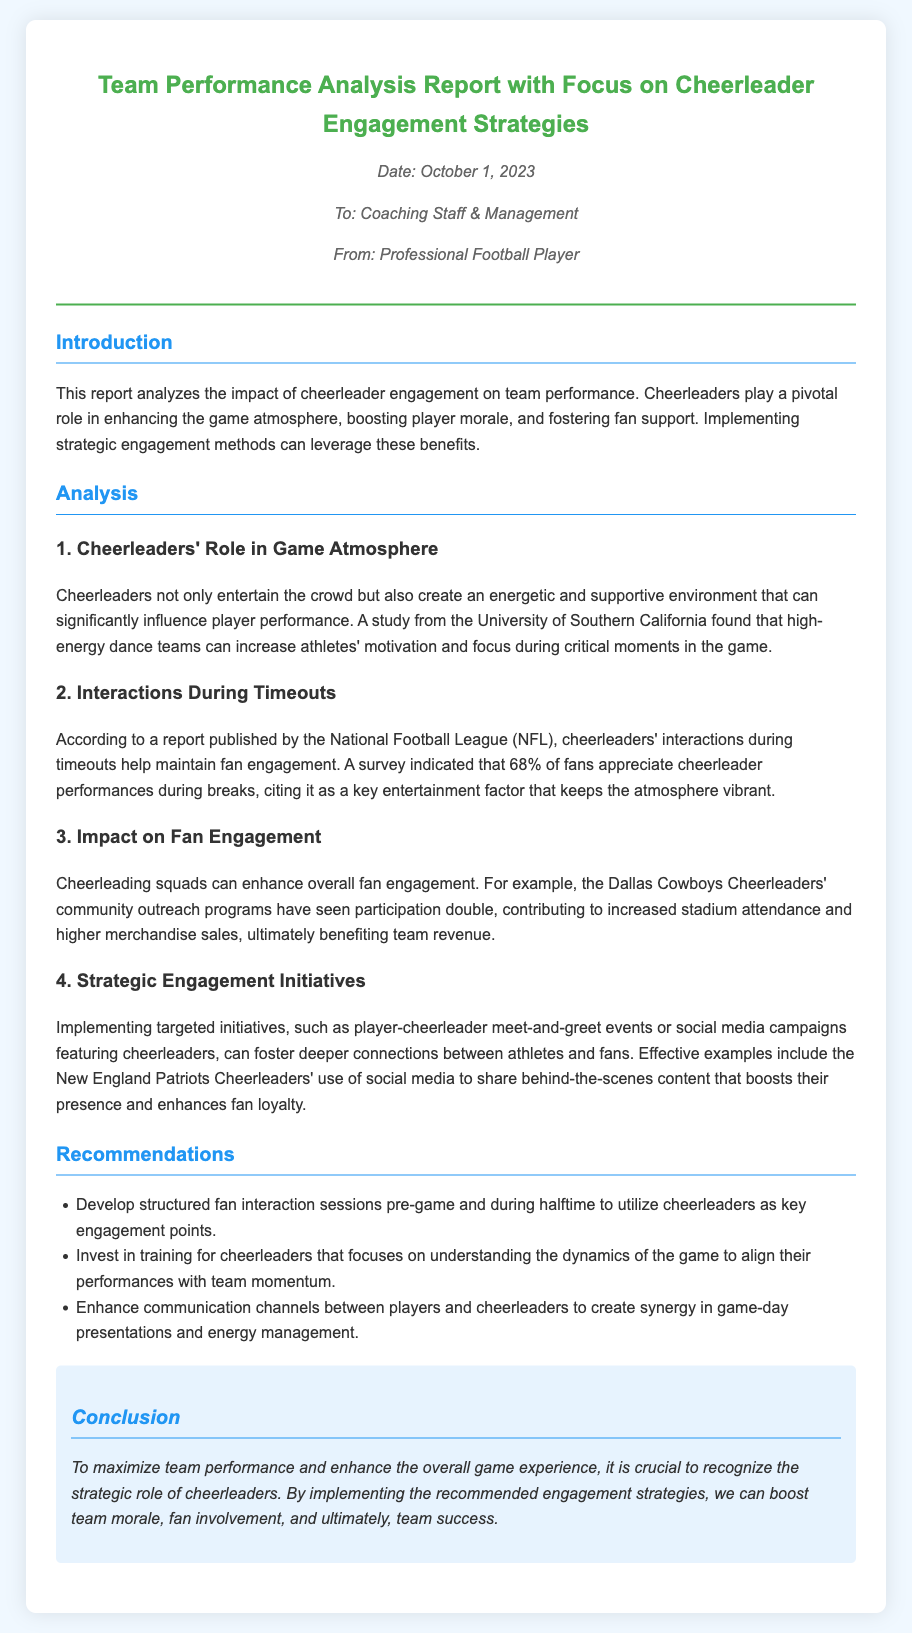what is the title of the memo? The title is prominently displayed at the top of the document, specifying the main focus of the report.
Answer: Team Performance Analysis Report with Focus on Cheerleader Engagement Strategies who is the memo addressed to? The memo indicates the recipients in the introductory section.
Answer: Coaching Staff & Management what date was the memo issued? The date is mentioned under the title in the meta section.
Answer: October 1, 2023 what percentage of fans appreciate cheerleader performances during breaks? This information is derived from a survey mentioned in the analysis section related to fan engagement and cheerleader interactions.
Answer: 68% which team's cheerleaders are mentioned for their community outreach programs? The document refers to a specific team to illustrate the positive impact of cheerleader initiatives on fan engagement.
Answer: Dallas Cowboys Cheerleaders what is one recommendation made in the memo? The memo lists several recommendations, and one can be extracted as part of the structured suggestions.
Answer: Develop structured fan interaction sessions pre-game and during halftime what is the main conclusion drawn in the memo? The conclusion summarizes the memo’s findings and emphasizes the importance of cheerleader engagement.
Answer: Recognize the strategic role of cheerleaders what university conducted a study about cheerleaders' impact on player motivation? The memo references this study in the context of cheerleaders enhancing game atmosphere and player focus.
Answer: University of Southern California what is suggested for cheerleader training in the recommendations? This suggestion highlights the importance of understanding the dynamics of the game, as mentioned in the recommendations section.
Answer: Understanding the dynamics of the game 